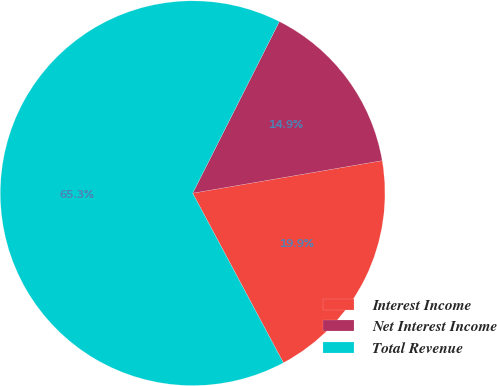<chart> <loc_0><loc_0><loc_500><loc_500><pie_chart><fcel>Interest Income<fcel>Net Interest Income<fcel>Total Revenue<nl><fcel>19.89%<fcel>14.85%<fcel>65.26%<nl></chart> 